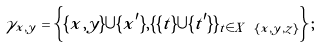<formula> <loc_0><loc_0><loc_500><loc_500>\gamma _ { x , y } = \left \{ \{ x , y \} \cup \{ x ^ { \prime } \} , \{ \{ t \} \cup \{ t ^ { \prime } \} \} _ { t \in X \ \{ x , y , z \} } \right \} ;</formula> 